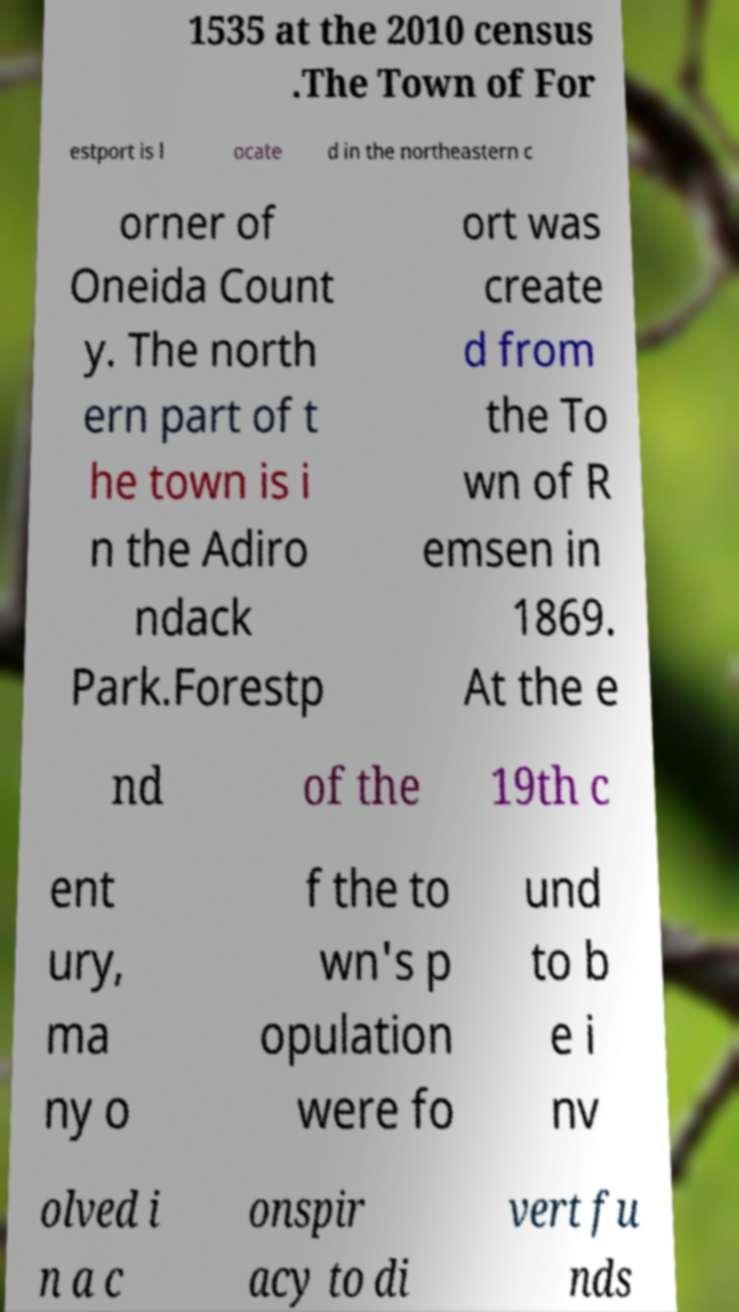For documentation purposes, I need the text within this image transcribed. Could you provide that? 1535 at the 2010 census .The Town of For estport is l ocate d in the northeastern c orner of Oneida Count y. The north ern part of t he town is i n the Adiro ndack Park.Forestp ort was create d from the To wn of R emsen in 1869. At the e nd of the 19th c ent ury, ma ny o f the to wn's p opulation were fo und to b e i nv olved i n a c onspir acy to di vert fu nds 